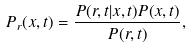Convert formula to latex. <formula><loc_0><loc_0><loc_500><loc_500>P _ { r } ( x , t ) = \frac { P ( r , t | x , t ) P ( x , t ) } { P ( r , t ) } ,</formula> 